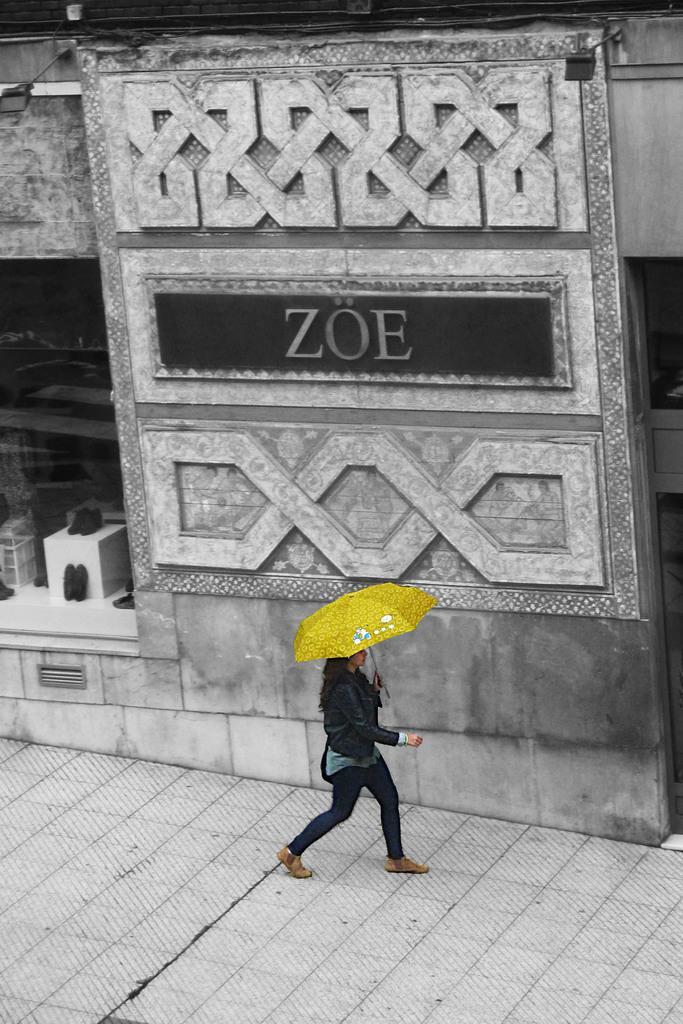Describe this image in one or two sentences. In this image I can see a woman is walking on the foot path by holding an umbrella in yellow color, she wore coat, trouser, shoes and it looks like a store, this image is in black and white color. 